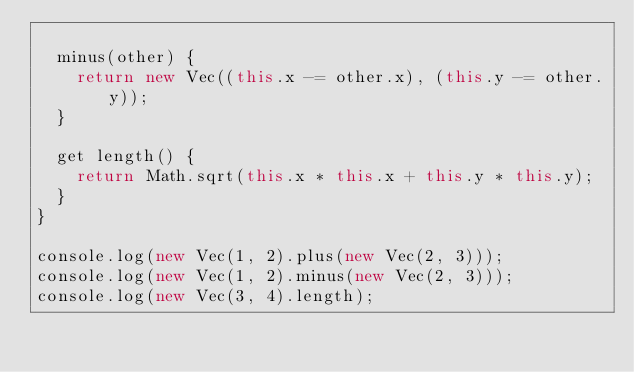Convert code to text. <code><loc_0><loc_0><loc_500><loc_500><_JavaScript_>
  minus(other) {
    return new Vec((this.x -= other.x), (this.y -= other.y));
  }

  get length() {
    return Math.sqrt(this.x * this.x + this.y * this.y);
  }
}

console.log(new Vec(1, 2).plus(new Vec(2, 3)));
console.log(new Vec(1, 2).minus(new Vec(2, 3)));
console.log(new Vec(3, 4).length);
</code> 